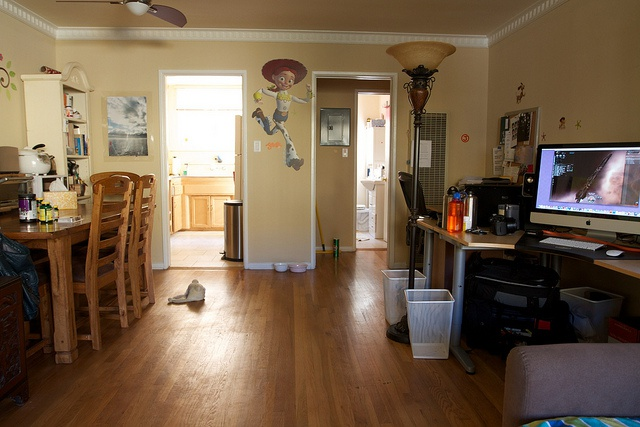Describe the objects in this image and their specific colors. I can see couch in darkgray, gray, and black tones, tv in darkgray, black, gray, and lightblue tones, chair in darkgray, maroon, black, and brown tones, dining table in darkgray, maroon, black, and tan tones, and chair in darkgray, maroon, brown, and gray tones in this image. 